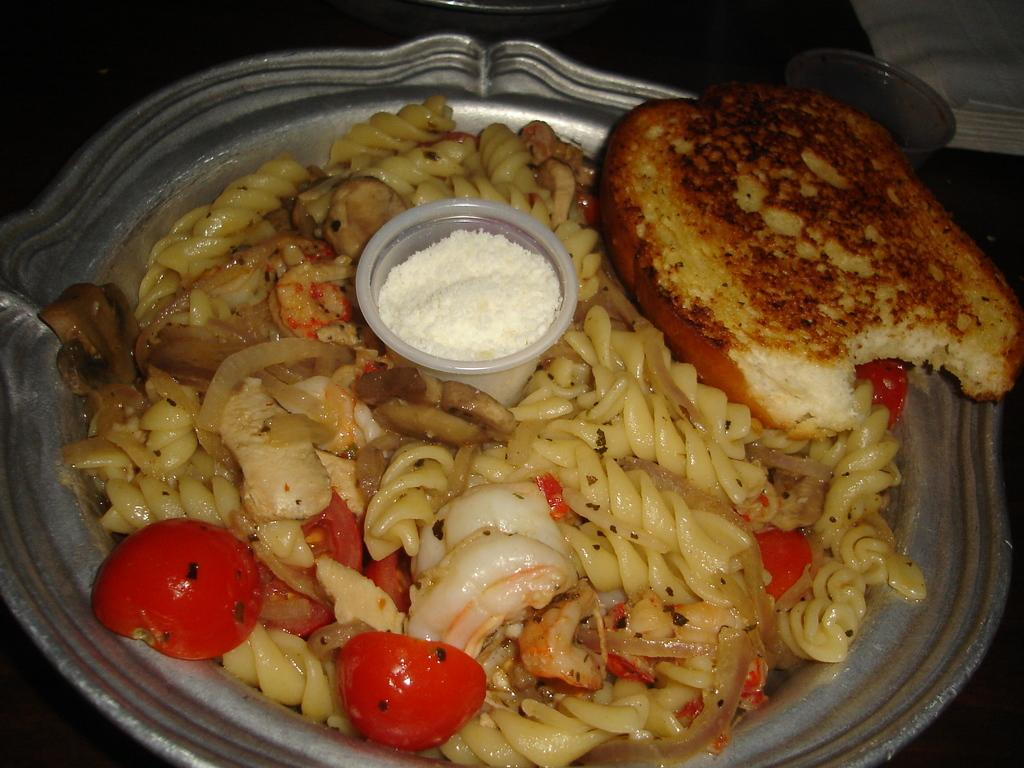What is present on the plate in the image? There is food in a plate in the image. What type of bubble is floating above the food in the image? There is no bubble present in the image; it only features a plate of food. 